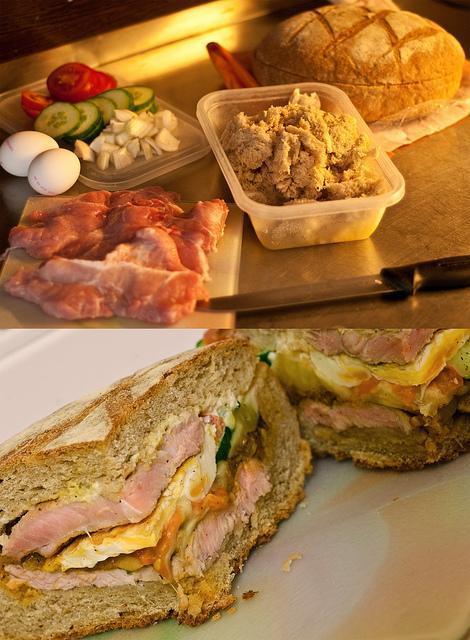How many sandwiches are visible?
Give a very brief answer. 2. 